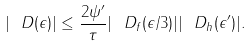Convert formula to latex. <formula><loc_0><loc_0><loc_500><loc_500>| \ D ( \epsilon ) | \leq \frac { 2 \| \psi ^ { \prime } \| } { \tau } | \ D _ { f } ( \epsilon / 3 ) | | \ D _ { h } ( \epsilon ^ { \prime } ) | .</formula> 